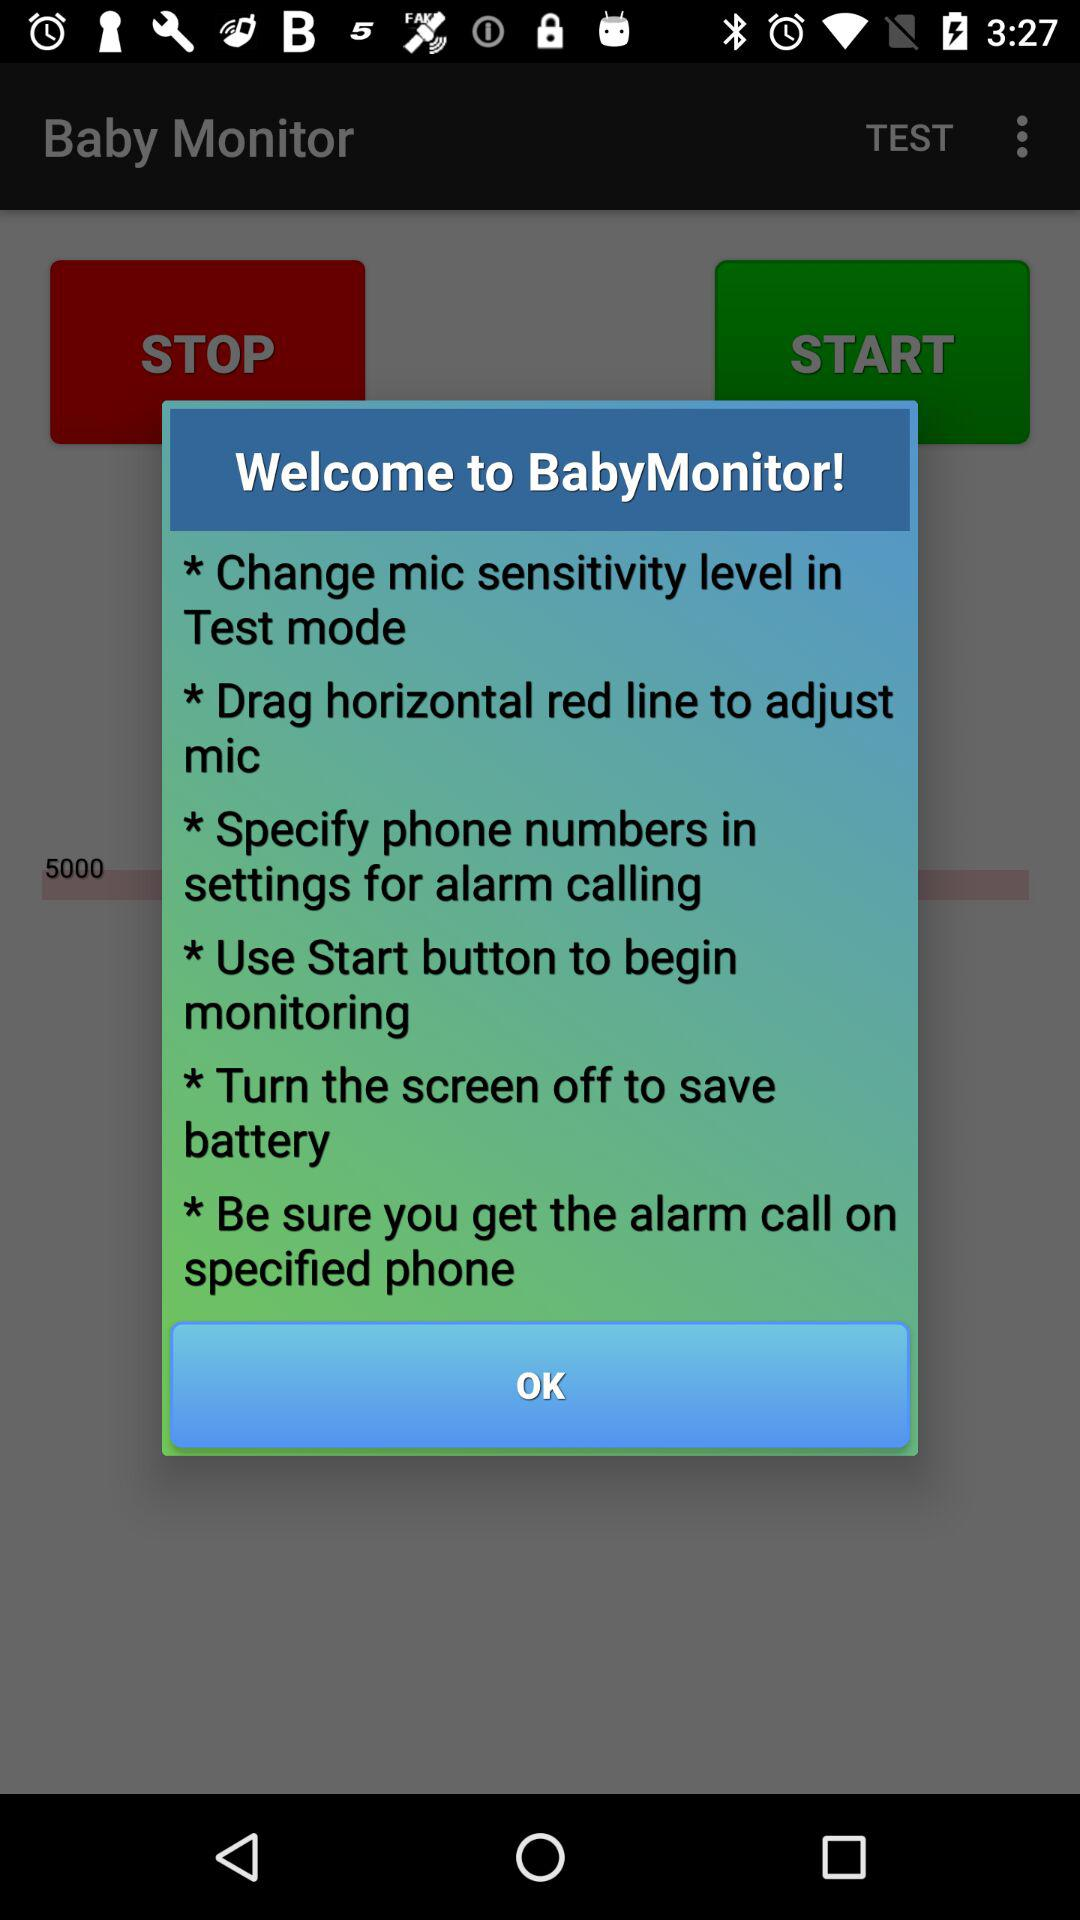How many more instructions are there about changing mic sensitivity than about turning the screen off?
Answer the question using a single word or phrase. 1 